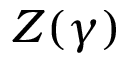<formula> <loc_0><loc_0><loc_500><loc_500>Z ( \gamma )</formula> 